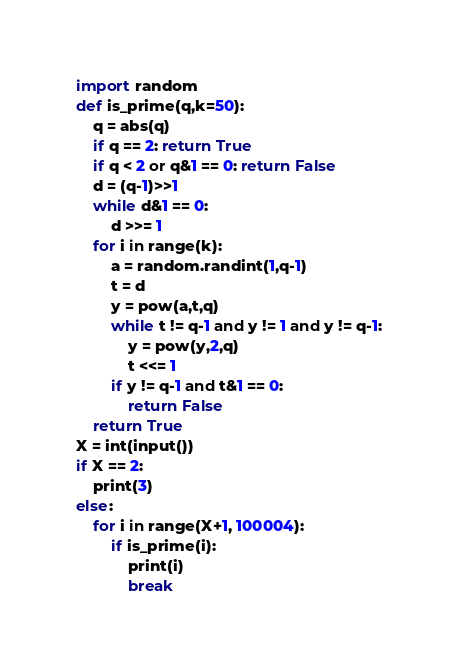<code> <loc_0><loc_0><loc_500><loc_500><_Python_>import random
def is_prime(q,k=50):
    q = abs(q)
    if q == 2: return True
    if q < 2 or q&1 == 0: return False
    d = (q-1)>>1
    while d&1 == 0:
        d >>= 1
    for i in range(k):
        a = random.randint(1,q-1)
        t = d
        y = pow(a,t,q)
        while t != q-1 and y != 1 and y != q-1: 
            y = pow(y,2,q)
            t <<= 1
        if y != q-1 and t&1 == 0:
            return False
    return True
X = int(input())
if X == 2:
    print(3)
else:
    for i in range(X+1, 100004):
        if is_prime(i):
            print(i)
            break
</code> 